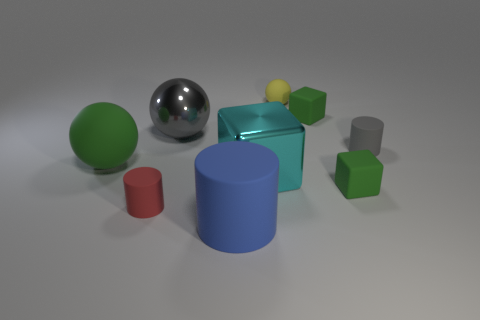Subtract all rubber cubes. How many cubes are left? 1 Add 1 cyan metal cubes. How many objects exist? 10 Subtract all yellow balls. How many balls are left? 2 Subtract all gray balls. How many green cubes are left? 2 Subtract 1 blocks. How many blocks are left? 2 Subtract all purple cylinders. Subtract all cyan spheres. How many cylinders are left? 3 Add 3 tiny yellow objects. How many tiny yellow objects exist? 4 Subtract 0 brown cylinders. How many objects are left? 9 Subtract all cylinders. How many objects are left? 6 Subtract all purple rubber spheres. Subtract all big blocks. How many objects are left? 8 